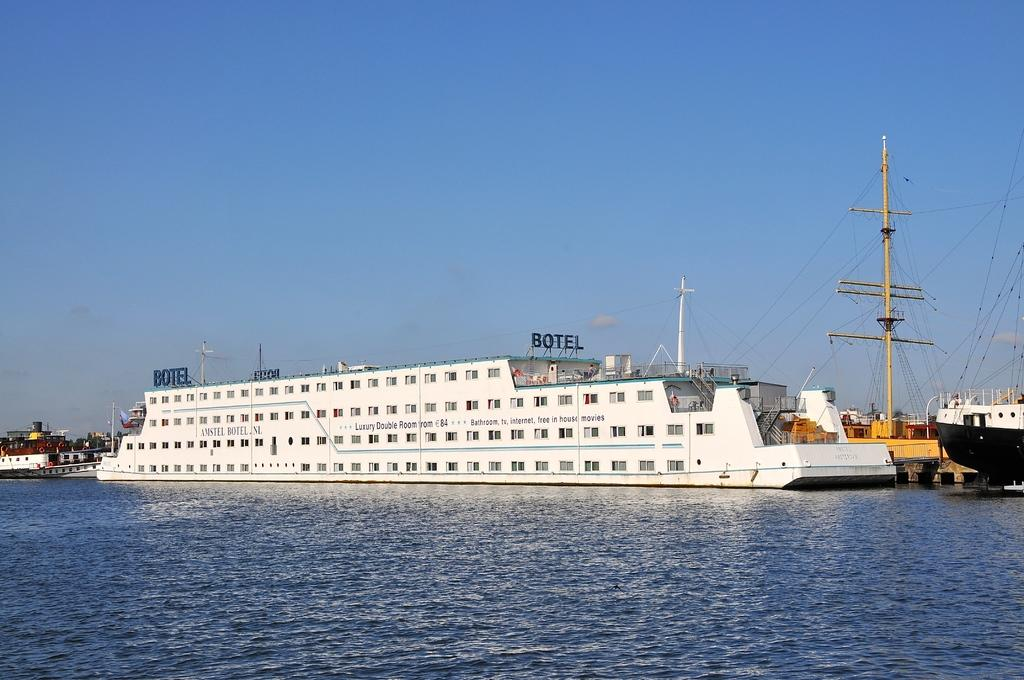What type of vehicles can be seen in the image? There are ships in the image. How many different colors can be observed on the ships? The ships are in different colors. What other objects are present in the image besides the ships? There are poles and wires in the image. What natural element is visible in the image? There is water visible in the image. What is the color of the sky in the image? The sky is blue in color. What type of story is being told by the fifth ship in the image? There is no fifth ship in the image, and therefore no story being told by it. 